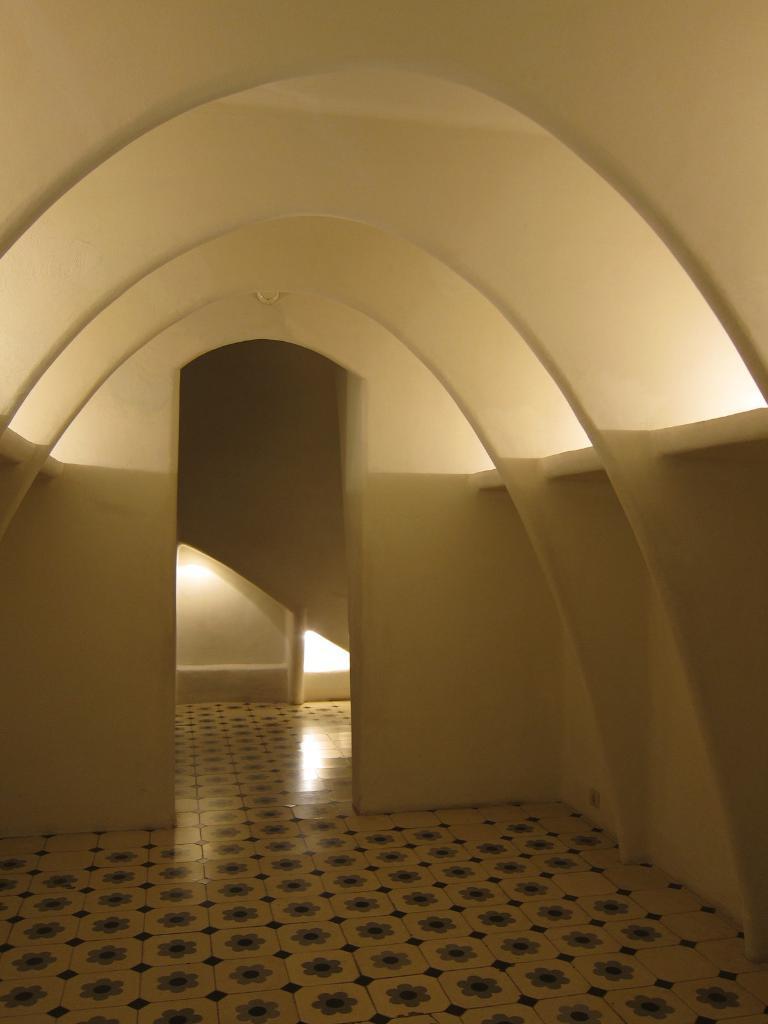Could you give a brief overview of what you see in this image? In this image I can see inside view of a building and there is a light focus visible on the wall in the middle. 